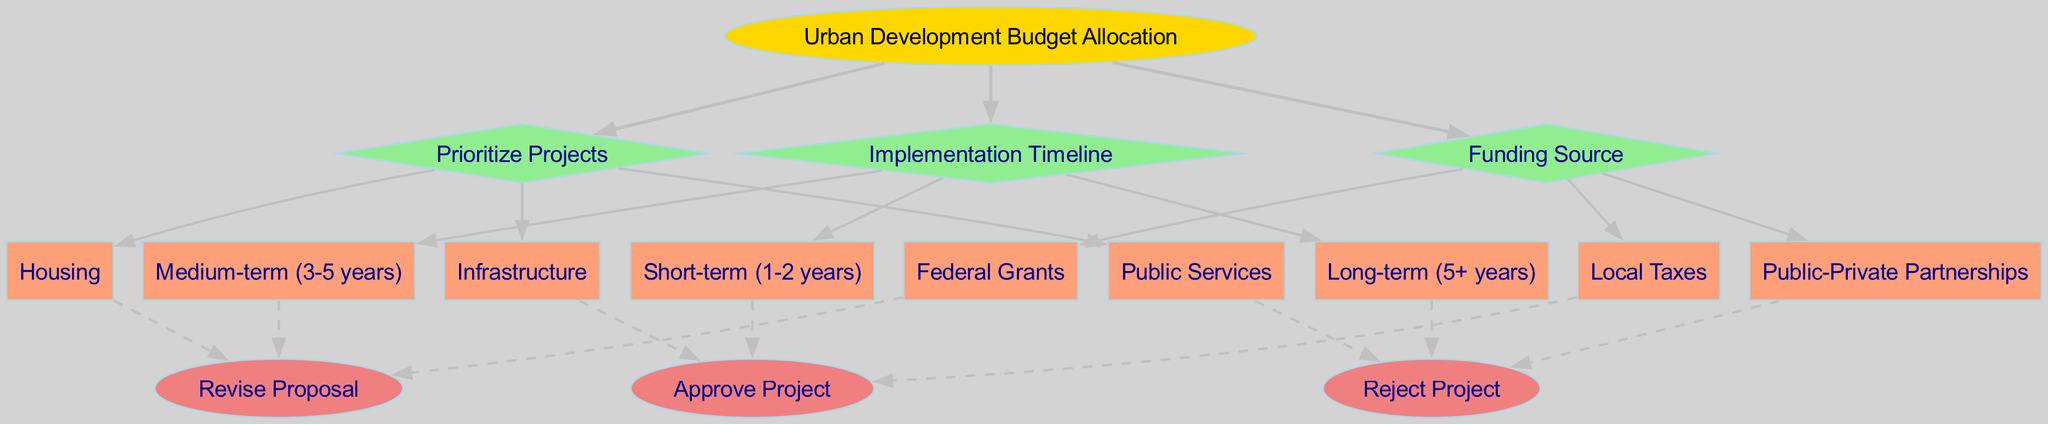What is the root node of the diagram? The root node is "Urban Development Budget Allocation," which is the starting point for the decision-making process in the diagram.
Answer: Urban Development Budget Allocation How many options are available under the "Prioritize Projects" decision? Under the "Prioritize Projects" decision node, there are three options: Infrastructure, Housing, and Public Services.
Answer: 3 What is one possible outcome if a project is approved? If a project is approved, the outcome is "Approve Project," which signifies that the project can proceed as planned.
Answer: Approve Project Which option is part of the "Funding Source" decision? One of the options under the "Funding Source" decision is "Federal Grants," which represents one way to finance projects.
Answer: Federal Grants If a project is rejected, what is one possible preceding decision node? One possible preceding decision node before a project is rejected is "Implementation Timeline," as the decision about how long the project will take can influence the approval process.
Answer: Implementation Timeline How many decision nodes are in the diagram? The diagram contains three decision nodes: "Prioritize Projects," "Funding Source," and "Implementation Timeline."
Answer: 3 What is the relationship between "Funding Source" and "Public Services"? "Public Services" is one of the options that could be prioritized within the decision node "Prioritize Projects," but it is not directly related to "Funding Source." They are separate decisions in the diagram.
Answer: No direct relationship Which option relates to the longest project duration? The longest project duration is associated with the "Long-term (5+ years)" option under the "Implementation Timeline" decision.
Answer: Long-term (5+ years) What shape represents the outcome nodes in the diagram? Outcome nodes are represented by an oval shape, indicating the final results of the decision-making process.
Answer: Oval 